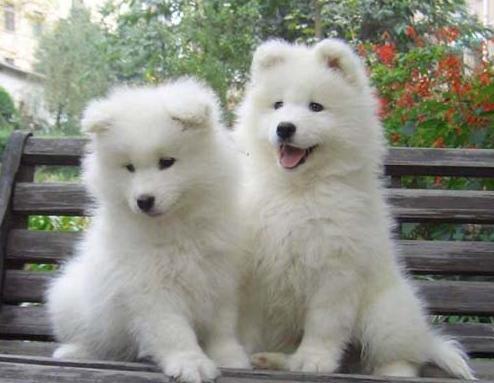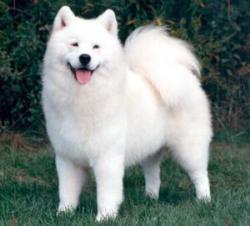The first image is the image on the left, the second image is the image on the right. Examine the images to the left and right. Is the description "An adult dog is lying down next to a puppy." accurate? Answer yes or no. No. 